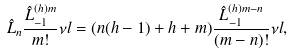Convert formula to latex. <formula><loc_0><loc_0><loc_500><loc_500>\hat { L } _ { n } \frac { \hat { L } _ { - 1 } ^ { ( h ) m } } { m ! } \nu l = ( n ( h - 1 ) + h + m ) \frac { \hat { L } _ { - 1 } ^ { ( h ) m - n } } { ( m - n ) ! } \nu l ,</formula> 